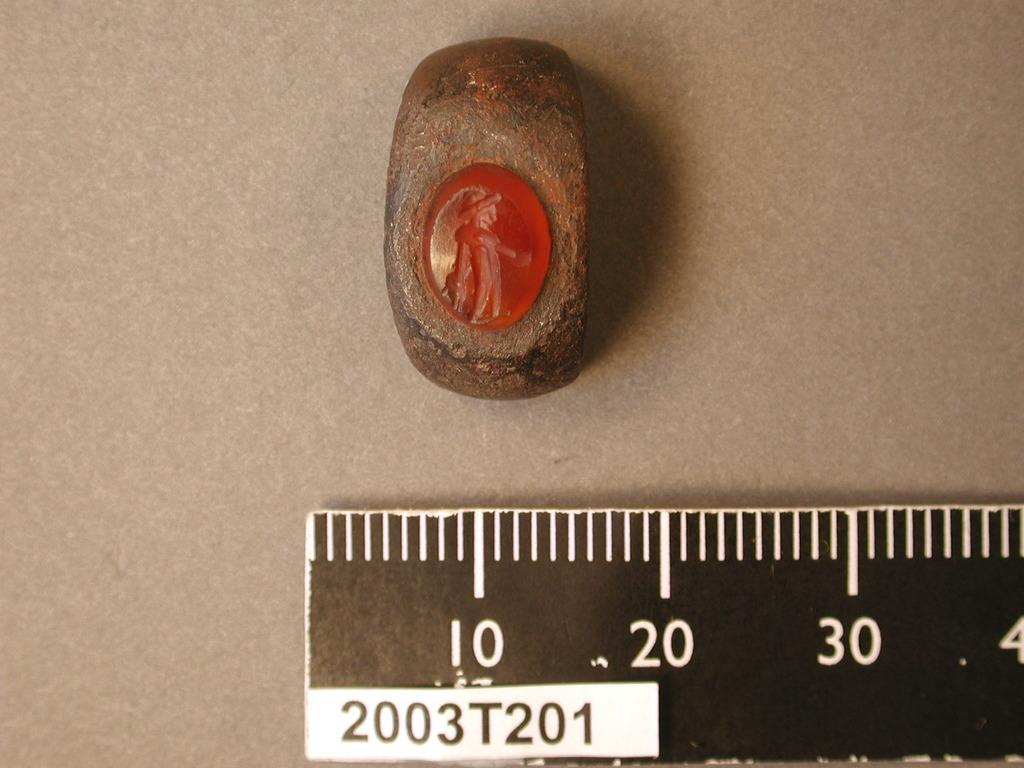<image>
Create a compact narrative representing the image presented. A rock that is 20 centimeters that has a carving of a person on it. 